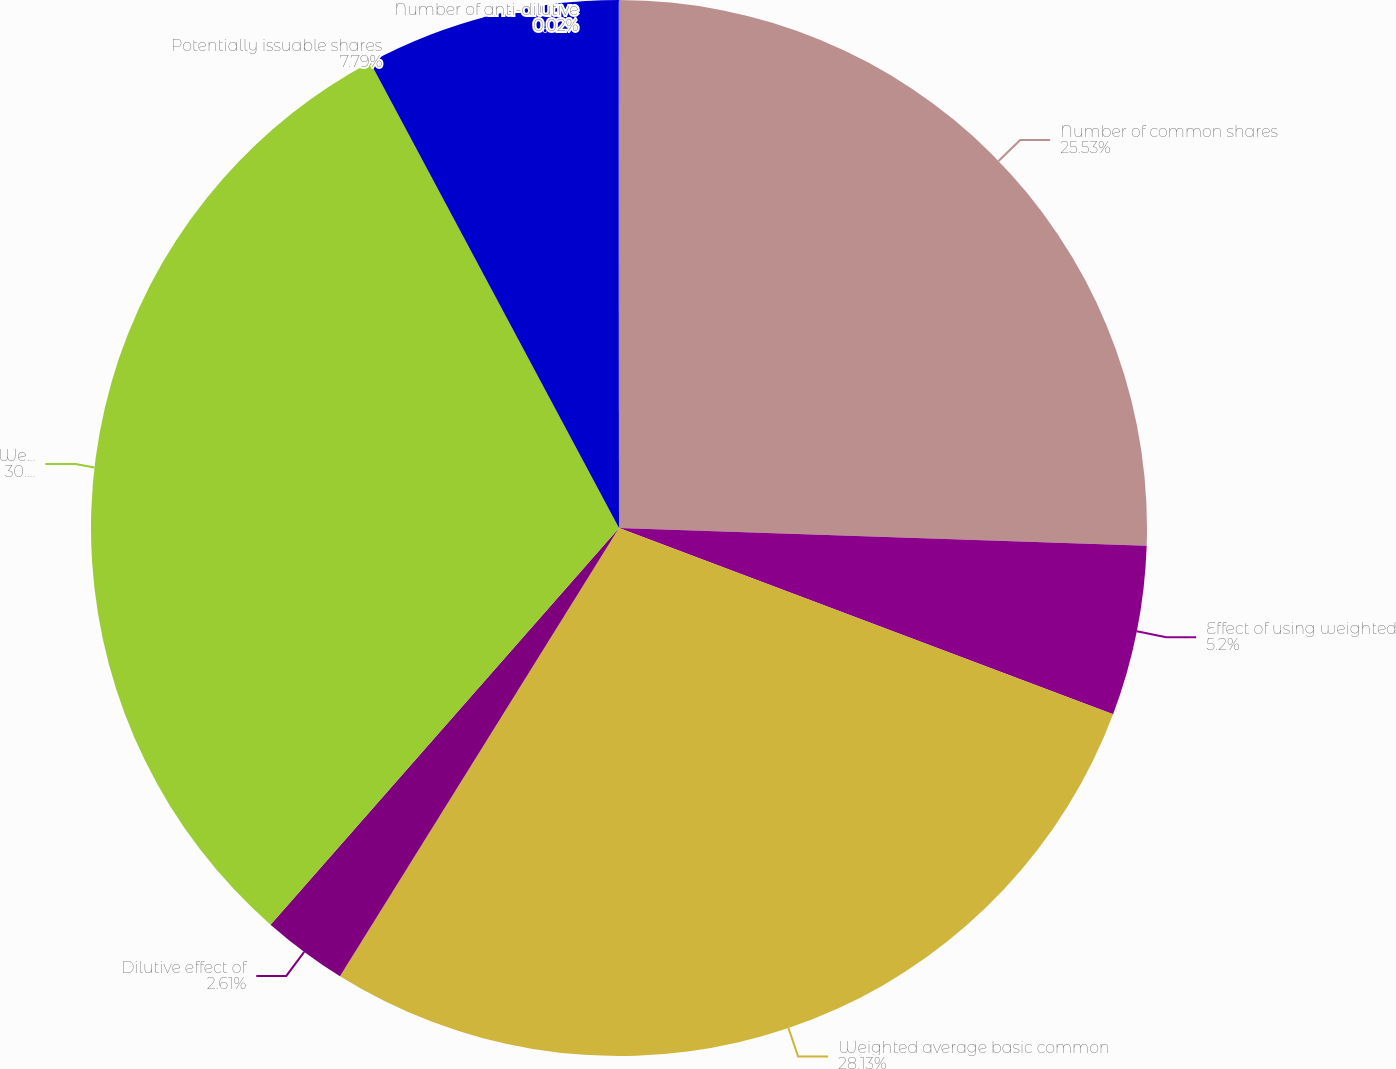<chart> <loc_0><loc_0><loc_500><loc_500><pie_chart><fcel>Number of common shares<fcel>Effect of using weighted<fcel>Weighted average basic common<fcel>Dilutive effect of<fcel>Weighted average diluted<fcel>Potentially issuable shares<fcel>Number of anti-dilutive<nl><fcel>25.53%<fcel>5.2%<fcel>28.12%<fcel>2.61%<fcel>30.71%<fcel>7.79%<fcel>0.02%<nl></chart> 